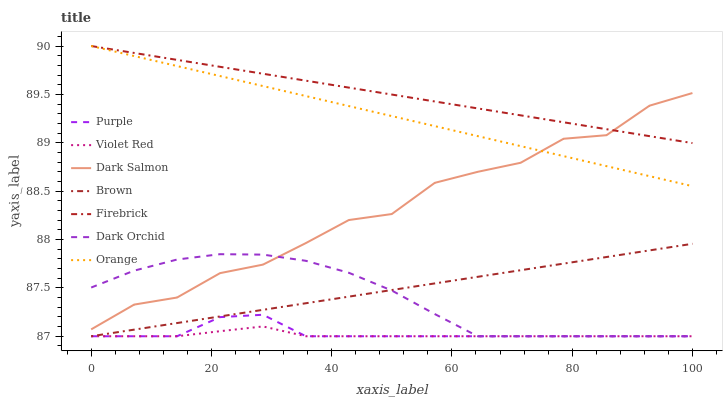Does Violet Red have the minimum area under the curve?
Answer yes or no. Yes. Does Firebrick have the maximum area under the curve?
Answer yes or no. Yes. Does Purple have the minimum area under the curve?
Answer yes or no. No. Does Purple have the maximum area under the curve?
Answer yes or no. No. Is Brown the smoothest?
Answer yes or no. Yes. Is Dark Salmon the roughest?
Answer yes or no. Yes. Is Violet Red the smoothest?
Answer yes or no. No. Is Violet Red the roughest?
Answer yes or no. No. Does Brown have the lowest value?
Answer yes or no. Yes. Does Firebrick have the lowest value?
Answer yes or no. No. Does Orange have the highest value?
Answer yes or no. Yes. Does Purple have the highest value?
Answer yes or no. No. Is Violet Red less than Dark Salmon?
Answer yes or no. Yes. Is Orange greater than Dark Orchid?
Answer yes or no. Yes. Does Firebrick intersect Dark Salmon?
Answer yes or no. Yes. Is Firebrick less than Dark Salmon?
Answer yes or no. No. Is Firebrick greater than Dark Salmon?
Answer yes or no. No. Does Violet Red intersect Dark Salmon?
Answer yes or no. No. 